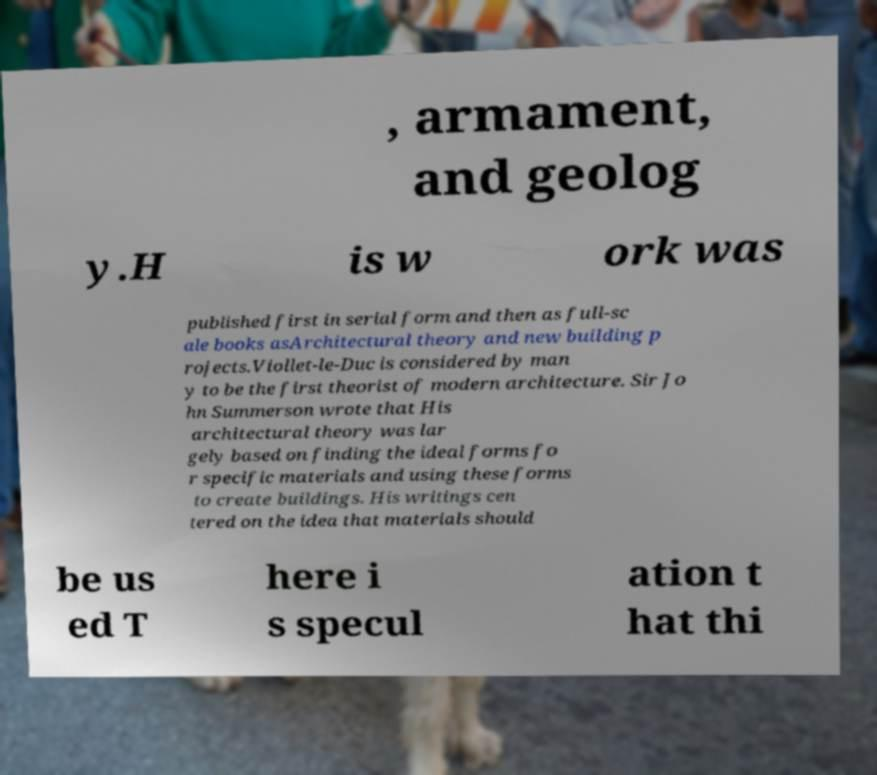Can you read and provide the text displayed in the image?This photo seems to have some interesting text. Can you extract and type it out for me? , armament, and geolog y.H is w ork was published first in serial form and then as full-sc ale books asArchitectural theory and new building p rojects.Viollet-le-Duc is considered by man y to be the first theorist of modern architecture. Sir Jo hn Summerson wrote that His architectural theory was lar gely based on finding the ideal forms fo r specific materials and using these forms to create buildings. His writings cen tered on the idea that materials should be us ed T here i s specul ation t hat thi 